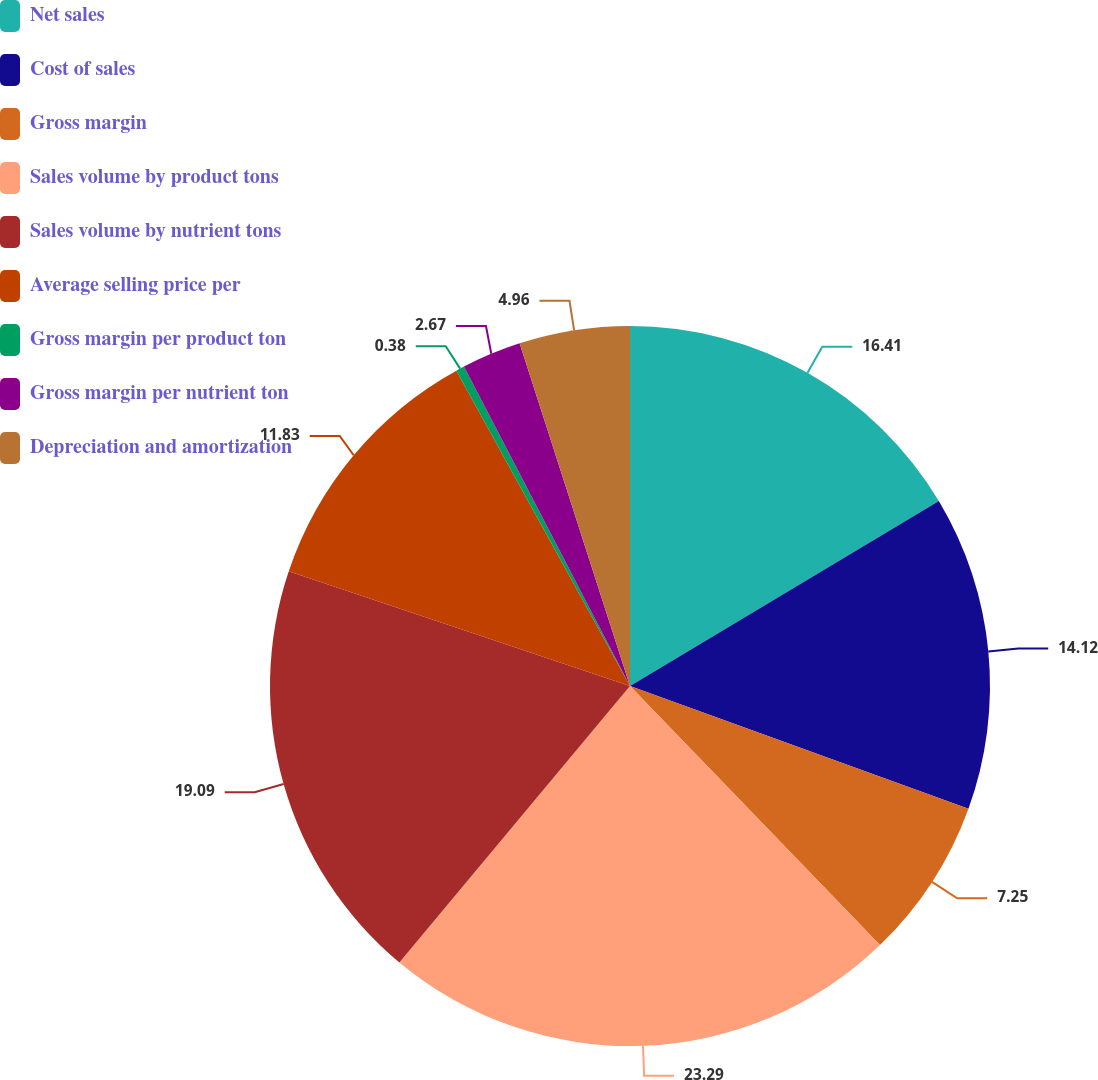<chart> <loc_0><loc_0><loc_500><loc_500><pie_chart><fcel>Net sales<fcel>Cost of sales<fcel>Gross margin<fcel>Sales volume by product tons<fcel>Sales volume by nutrient tons<fcel>Average selling price per<fcel>Gross margin per product ton<fcel>Gross margin per nutrient ton<fcel>Depreciation and amortization<nl><fcel>16.41%<fcel>14.12%<fcel>7.25%<fcel>23.28%<fcel>19.09%<fcel>11.83%<fcel>0.38%<fcel>2.67%<fcel>4.96%<nl></chart> 